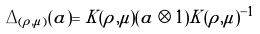<formula> <loc_0><loc_0><loc_500><loc_500>\Delta _ { ( \rho , \mu ) } ( a ) = K ( \rho , \mu ) ( a \otimes 1 ) K ( \rho , \mu ) ^ { - 1 }</formula> 